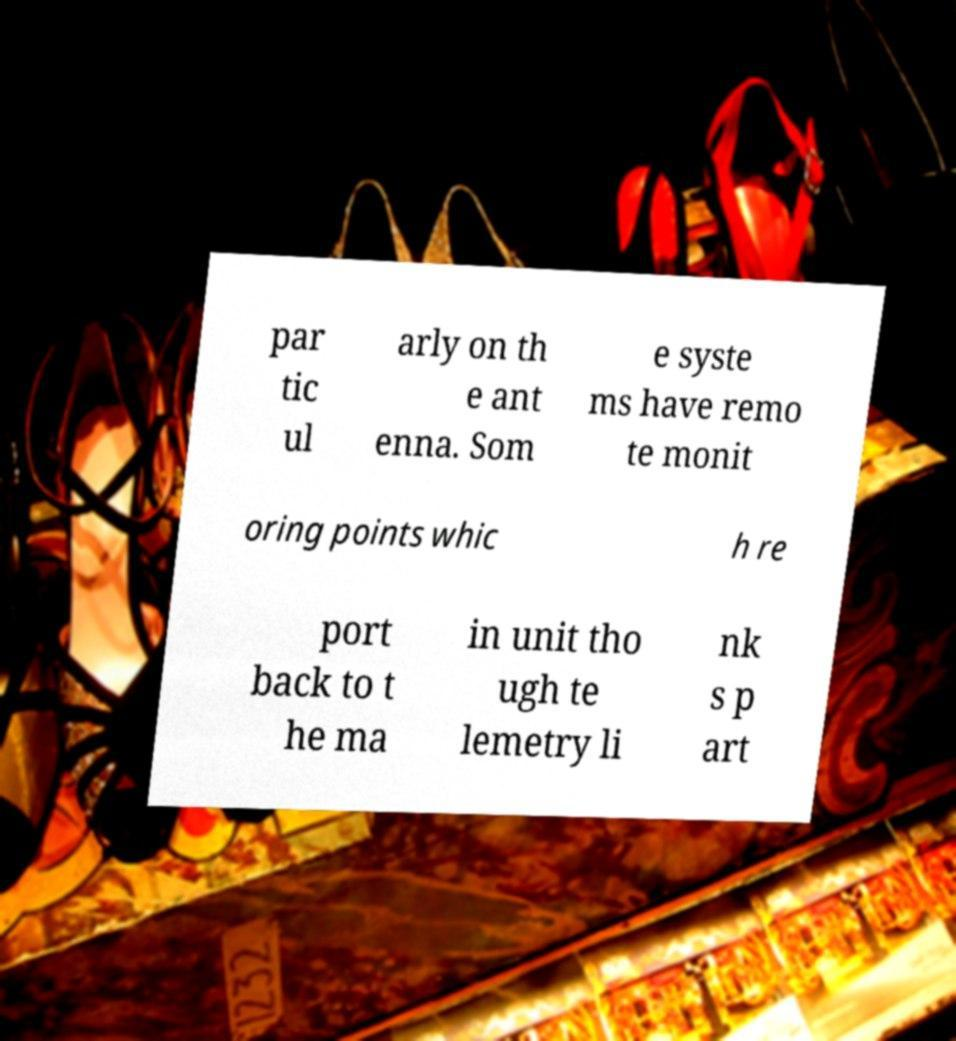I need the written content from this picture converted into text. Can you do that? par tic ul arly on th e ant enna. Som e syste ms have remo te monit oring points whic h re port back to t he ma in unit tho ugh te lemetry li nk s p art 